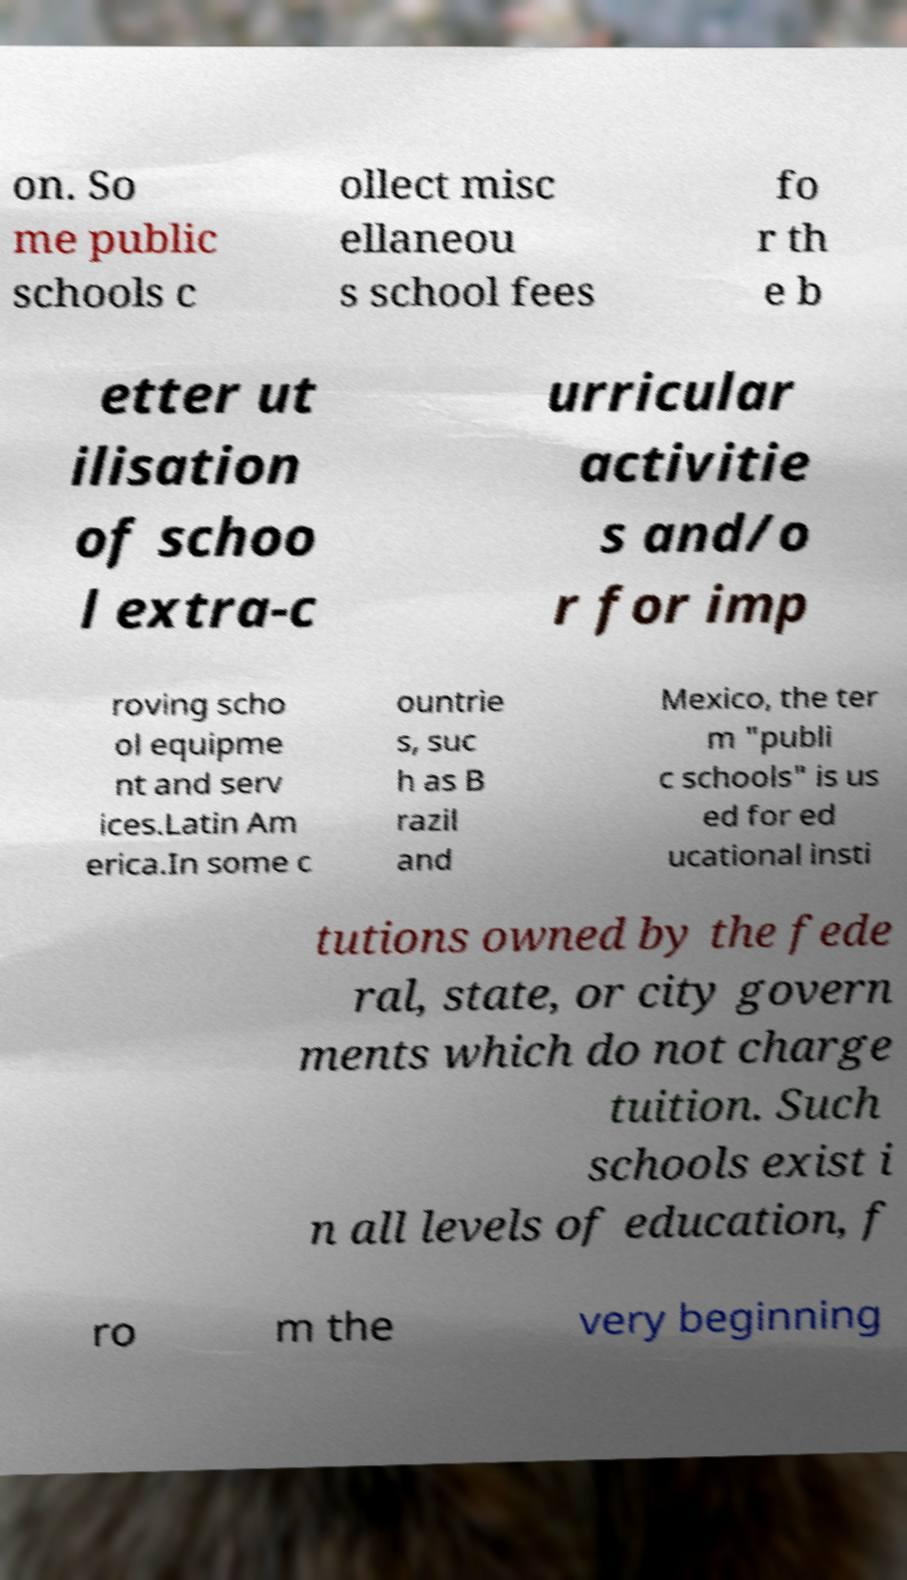Could you extract and type out the text from this image? on. So me public schools c ollect misc ellaneou s school fees fo r th e b etter ut ilisation of schoo l extra-c urricular activitie s and/o r for imp roving scho ol equipme nt and serv ices.Latin Am erica.In some c ountrie s, suc h as B razil and Mexico, the ter m "publi c schools" is us ed for ed ucational insti tutions owned by the fede ral, state, or city govern ments which do not charge tuition. Such schools exist i n all levels of education, f ro m the very beginning 